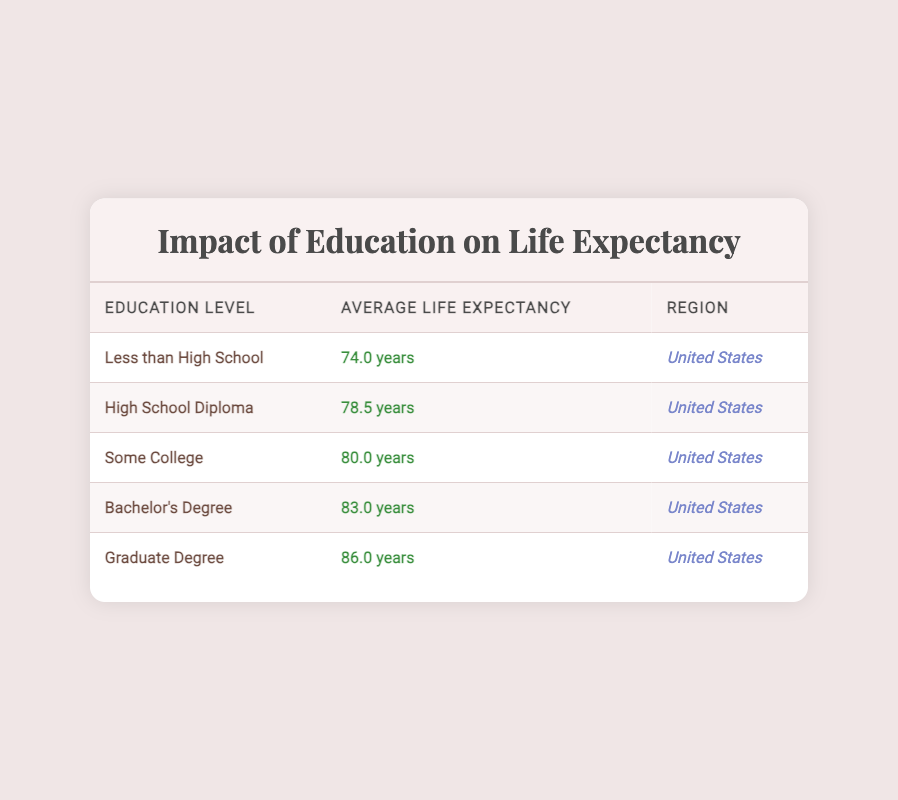What is the average life expectancy for someone with a Graduate Degree? The table shows that the average life expectancy for someone with a Graduate Degree is 86.0 years.
Answer: 86.0 years Which education level has the lowest average life expectancy? According to the table, "Less than High School" has the lowest average life expectancy at 74.0 years.
Answer: Less than High School What is the difference in life expectancy between those with a Bachelor's Degree and those with a High School Diploma? The average life expectancy for a Bachelor's Degree is 83.0 years, and for a High School Diploma, it is 78.5 years. The difference is 83.0 - 78.5 = 4.5 years.
Answer: 4.5 years Is it true that the average life expectancy for individuals with some college is 78.5 years? The table indicates that the average life expectancy for individuals with some college is actually 80.0 years, not 78.5 years.
Answer: No What is the average life expectancy for the education levels of High School Diploma and Some College combined? For High School Diploma, the average is 78.5 years, and for Some College, it is 80.0 years. To find the average, add both values: 78.5 + 80.0 = 158.5, and divide by 2. Thus, the average is 158.5 / 2 = 79.25 years.
Answer: 79.25 years How many years longer do individuals with a Graduate Degree live compared to those who completed Less than High School? The average life expectancy for a Graduate Degree is 86.0 years, and for Less than High School, it is 74.0 years. The difference is 86.0 - 74.0 = 12.0 years.
Answer: 12.0 years Which education level corresponds to an average life expectancy of 80.0 years? The "Some College" education level corresponds to an average life expectancy of 80.0 years, according to the table.
Answer: Some College 